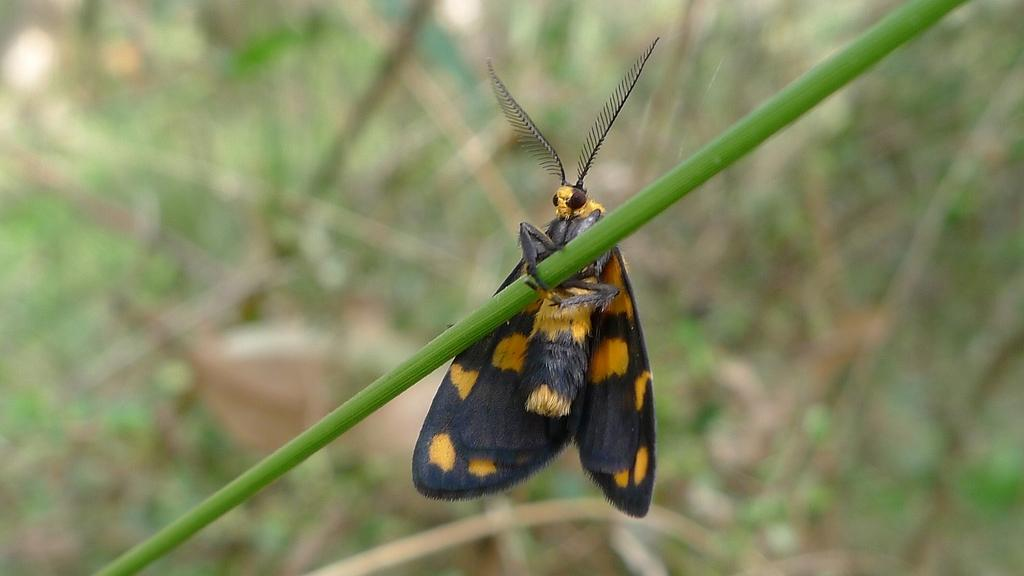What type of creature is present in the image? There is an insect in the image. Where is the insect located? The insect is on a stem. What can be observed about the background of the image? The background of the image is blurred. What type of secretary can be seen in the image? There is no secretary present in the image; it features an insect on a stem. What type of jar is visible in the image? There is no jar present in the image. 